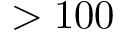<formula> <loc_0><loc_0><loc_500><loc_500>> 1 0 0</formula> 